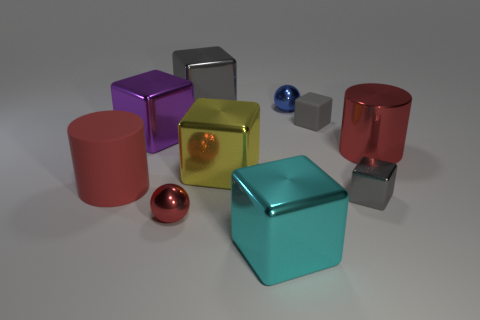Subtract all big purple blocks. How many blocks are left? 5 Subtract all red balls. How many gray cubes are left? 3 Subtract all cyan blocks. How many blocks are left? 5 Subtract all balls. How many objects are left? 8 Subtract all yellow blocks. Subtract all cyan cylinders. How many blocks are left? 5 Add 5 small purple cylinders. How many small purple cylinders exist? 5 Subtract 3 gray cubes. How many objects are left? 7 Subtract all gray balls. Subtract all large yellow blocks. How many objects are left? 9 Add 4 big red shiny cylinders. How many big red shiny cylinders are left? 5 